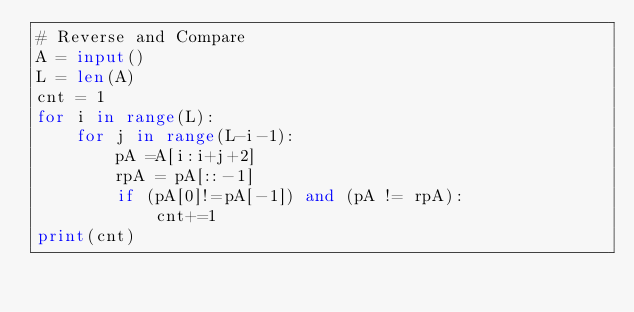<code> <loc_0><loc_0><loc_500><loc_500><_Python_># Reverse and Compare
A = input()
L = len(A)
cnt = 1
for i in range(L):
    for j in range(L-i-1):
        pA =A[i:i+j+2]
        rpA = pA[::-1]
        if (pA[0]!=pA[-1]) and (pA != rpA):
            cnt+=1
print(cnt)</code> 